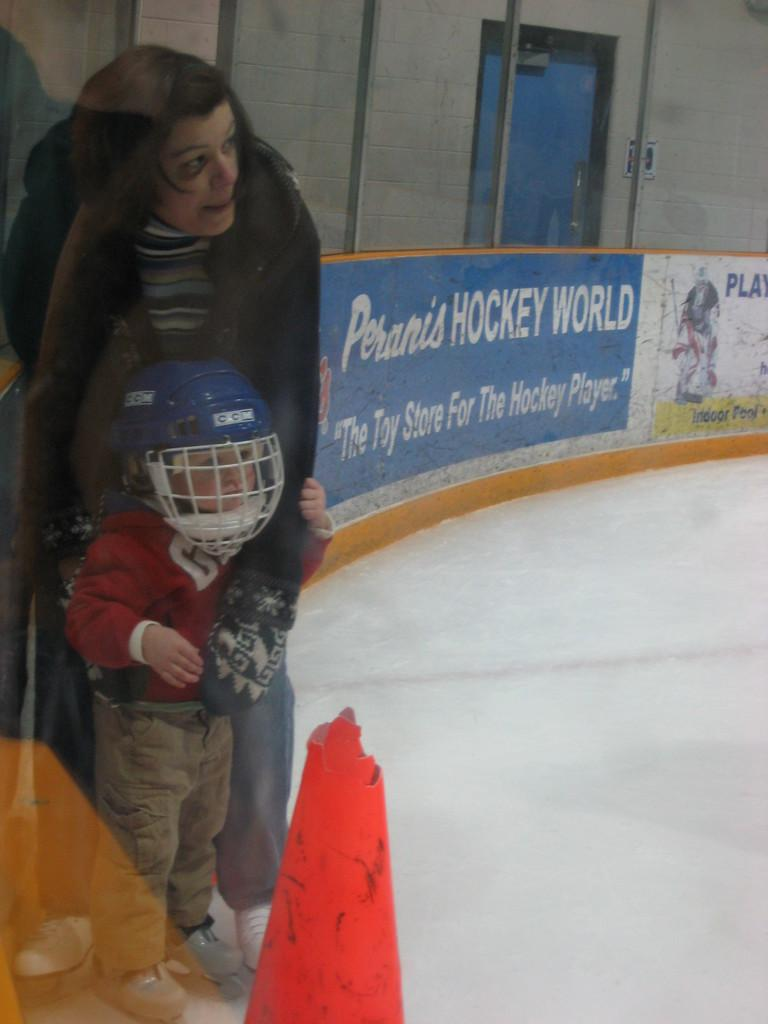Who is present in the image? There is a woman in the image. What is the woman doing in the image? The woman is holding a kid. What is the kid wearing in the image? The kid is wearing a helmet. What is the terrain like in the image? The land is covered with ice. What type of signage is visible in the image? There is a hoarding in the image. What type of card is the woman using to keep the ice from melting in the image? There is no card present in the image, and the ice is not melting. 